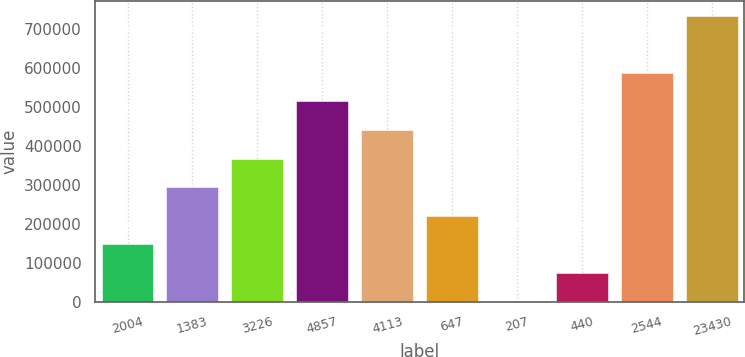<chart> <loc_0><loc_0><loc_500><loc_500><bar_chart><fcel>2004<fcel>1383<fcel>3226<fcel>4857<fcel>4113<fcel>647<fcel>207<fcel>440<fcel>2544<fcel>23430<nl><fcel>147356<fcel>293856<fcel>367106<fcel>513607<fcel>440357<fcel>220606<fcel>856<fcel>74106.1<fcel>586857<fcel>733357<nl></chart> 